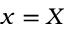Convert formula to latex. <formula><loc_0><loc_0><loc_500><loc_500>x = X</formula> 